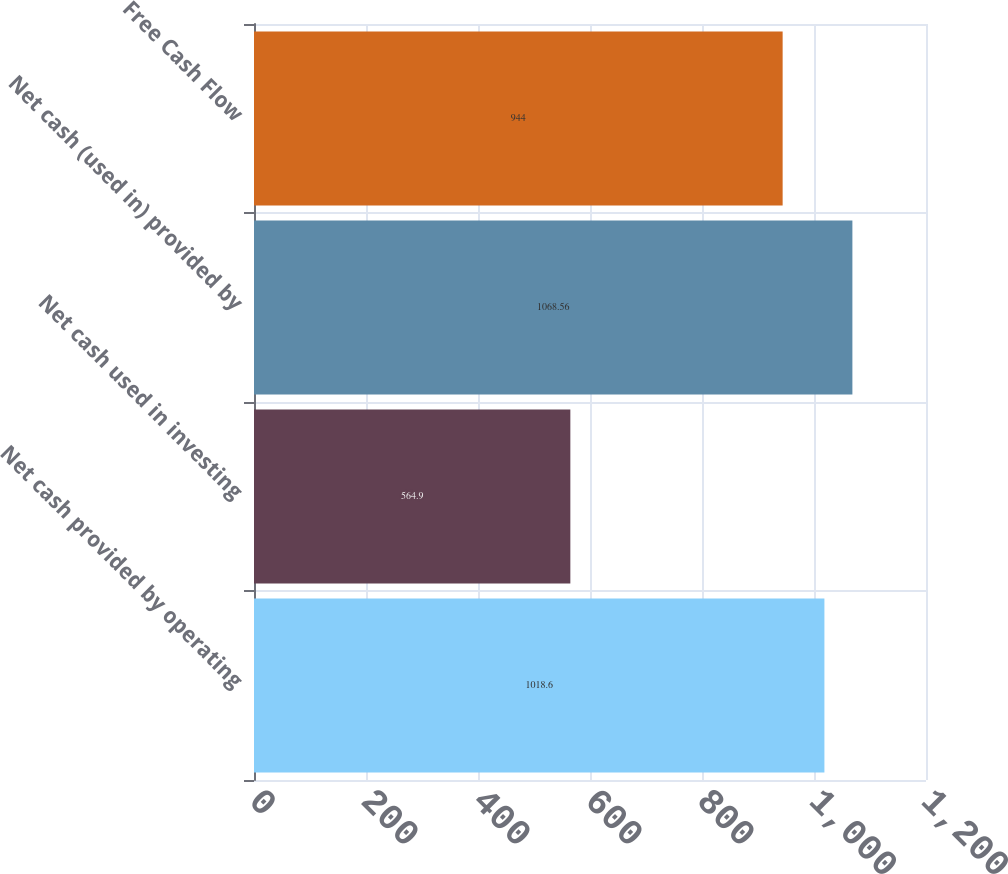<chart> <loc_0><loc_0><loc_500><loc_500><bar_chart><fcel>Net cash provided by operating<fcel>Net cash used in investing<fcel>Net cash (used in) provided by<fcel>Free Cash Flow<nl><fcel>1018.6<fcel>564.9<fcel>1068.56<fcel>944<nl></chart> 